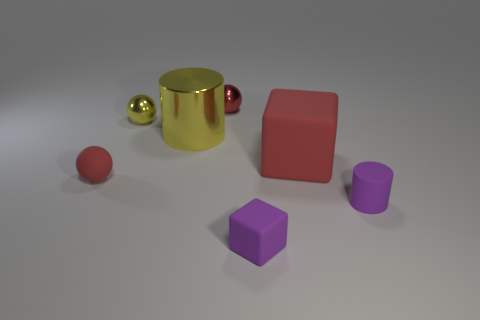There is a yellow cylinder; what number of small red metallic balls are behind it?
Your answer should be very brief. 1. How big is the red thing to the left of the red sphere on the right side of the tiny red matte object?
Ensure brevity in your answer.  Small. Does the metal thing on the left side of the yellow cylinder have the same shape as the purple rubber thing in front of the tiny purple cylinder?
Provide a succinct answer. No. There is a small purple rubber thing on the left side of the block that is behind the small cylinder; what shape is it?
Your response must be concise. Cube. There is a thing that is both behind the big cylinder and on the right side of the small yellow metallic sphere; what is its size?
Offer a terse response. Small. Is the shape of the tiny red metallic thing the same as the big object to the right of the tiny red metal object?
Make the answer very short. No. There is a purple object that is the same shape as the large yellow object; what size is it?
Make the answer very short. Small. Does the tiny rubber cylinder have the same color as the sphere that is right of the yellow cylinder?
Make the answer very short. No. What number of other objects are there of the same size as the purple rubber cylinder?
Make the answer very short. 4. The tiny object that is right of the small thing that is in front of the purple object that is to the right of the big matte thing is what shape?
Make the answer very short. Cylinder. 